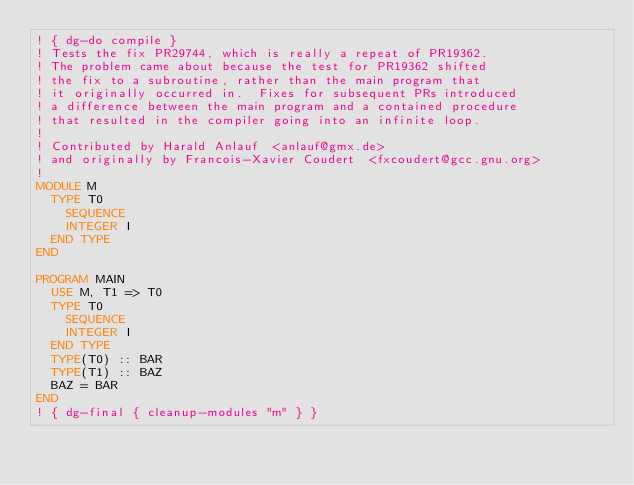<code> <loc_0><loc_0><loc_500><loc_500><_FORTRAN_>! { dg-do compile }
! Tests the fix PR29744, which is really a repeat of PR19362.
! The problem came about because the test for PR19362 shifted
! the fix to a subroutine, rather than the main program that
! it originally occurred in.  Fixes for subsequent PRs introduced
! a difference between the main program and a contained procedure
! that resulted in the compiler going into an infinite loop.
!
! Contributed by Harald Anlauf  <anlauf@gmx.de>
! and originally by Francois-Xavier Coudert  <fxcoudert@gcc.gnu.org> 
!
MODULE M
  TYPE T0
    SEQUENCE
    INTEGER I
  END TYPE
END

PROGRAM MAIN
  USE M, T1 => T0
  TYPE T0
    SEQUENCE
    INTEGER I
  END TYPE
  TYPE(T0) :: BAR
  TYPE(T1) :: BAZ
  BAZ = BAR
END
! { dg-final { cleanup-modules "m" } }

</code> 